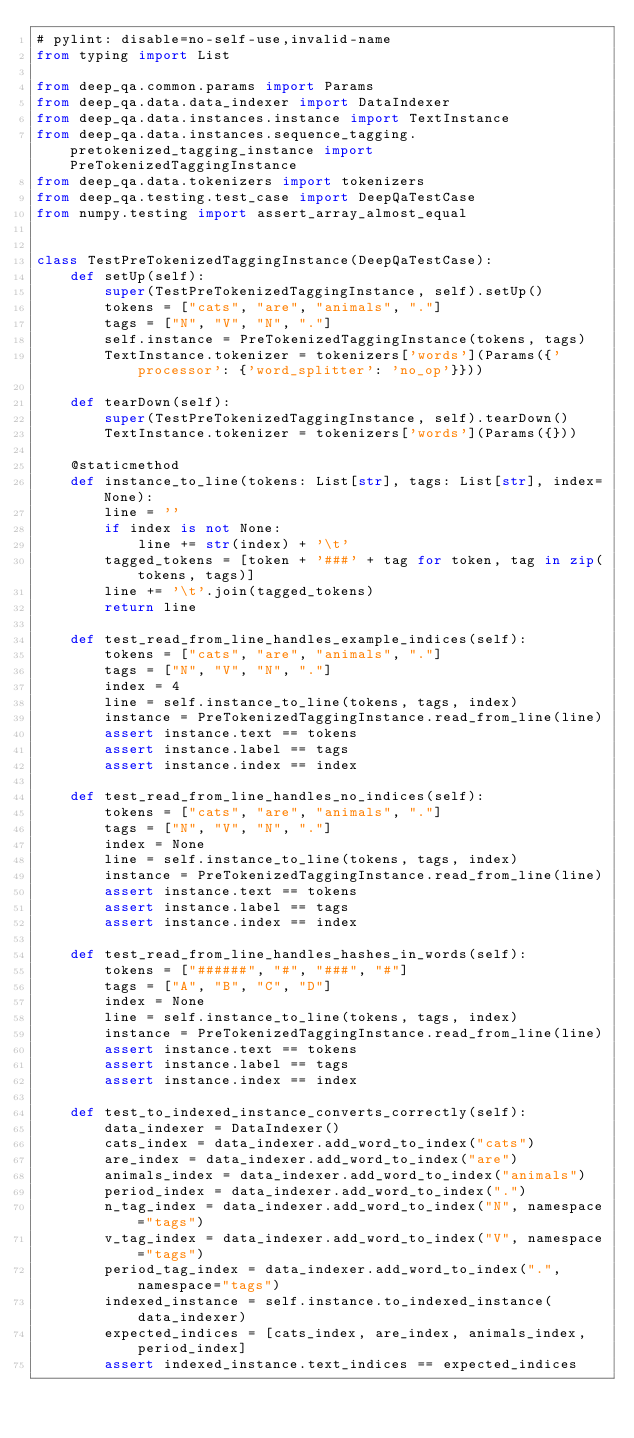<code> <loc_0><loc_0><loc_500><loc_500><_Python_># pylint: disable=no-self-use,invalid-name
from typing import List

from deep_qa.common.params import Params
from deep_qa.data.data_indexer import DataIndexer
from deep_qa.data.instances.instance import TextInstance
from deep_qa.data.instances.sequence_tagging.pretokenized_tagging_instance import PreTokenizedTaggingInstance
from deep_qa.data.tokenizers import tokenizers
from deep_qa.testing.test_case import DeepQaTestCase
from numpy.testing import assert_array_almost_equal


class TestPreTokenizedTaggingInstance(DeepQaTestCase):
    def setUp(self):
        super(TestPreTokenizedTaggingInstance, self).setUp()
        tokens = ["cats", "are", "animals", "."]
        tags = ["N", "V", "N", "."]
        self.instance = PreTokenizedTaggingInstance(tokens, tags)
        TextInstance.tokenizer = tokenizers['words'](Params({'processor': {'word_splitter': 'no_op'}}))

    def tearDown(self):
        super(TestPreTokenizedTaggingInstance, self).tearDown()
        TextInstance.tokenizer = tokenizers['words'](Params({}))

    @staticmethod
    def instance_to_line(tokens: List[str], tags: List[str], index=None):
        line = ''
        if index is not None:
            line += str(index) + '\t'
        tagged_tokens = [token + '###' + tag for token, tag in zip(tokens, tags)]
        line += '\t'.join(tagged_tokens)
        return line

    def test_read_from_line_handles_example_indices(self):
        tokens = ["cats", "are", "animals", "."]
        tags = ["N", "V", "N", "."]
        index = 4
        line = self.instance_to_line(tokens, tags, index)
        instance = PreTokenizedTaggingInstance.read_from_line(line)
        assert instance.text == tokens
        assert instance.label == tags
        assert instance.index == index

    def test_read_from_line_handles_no_indices(self):
        tokens = ["cats", "are", "animals", "."]
        tags = ["N", "V", "N", "."]
        index = None
        line = self.instance_to_line(tokens, tags, index)
        instance = PreTokenizedTaggingInstance.read_from_line(line)
        assert instance.text == tokens
        assert instance.label == tags
        assert instance.index == index

    def test_read_from_line_handles_hashes_in_words(self):
        tokens = ["######", "#", "###", "#"]
        tags = ["A", "B", "C", "D"]
        index = None
        line = self.instance_to_line(tokens, tags, index)
        instance = PreTokenizedTaggingInstance.read_from_line(line)
        assert instance.text == tokens
        assert instance.label == tags
        assert instance.index == index

    def test_to_indexed_instance_converts_correctly(self):
        data_indexer = DataIndexer()
        cats_index = data_indexer.add_word_to_index("cats")
        are_index = data_indexer.add_word_to_index("are")
        animals_index = data_indexer.add_word_to_index("animals")
        period_index = data_indexer.add_word_to_index(".")
        n_tag_index = data_indexer.add_word_to_index("N", namespace="tags")
        v_tag_index = data_indexer.add_word_to_index("V", namespace="tags")
        period_tag_index = data_indexer.add_word_to_index(".", namespace="tags")
        indexed_instance = self.instance.to_indexed_instance(data_indexer)
        expected_indices = [cats_index, are_index, animals_index, period_index]
        assert indexed_instance.text_indices == expected_indices</code> 